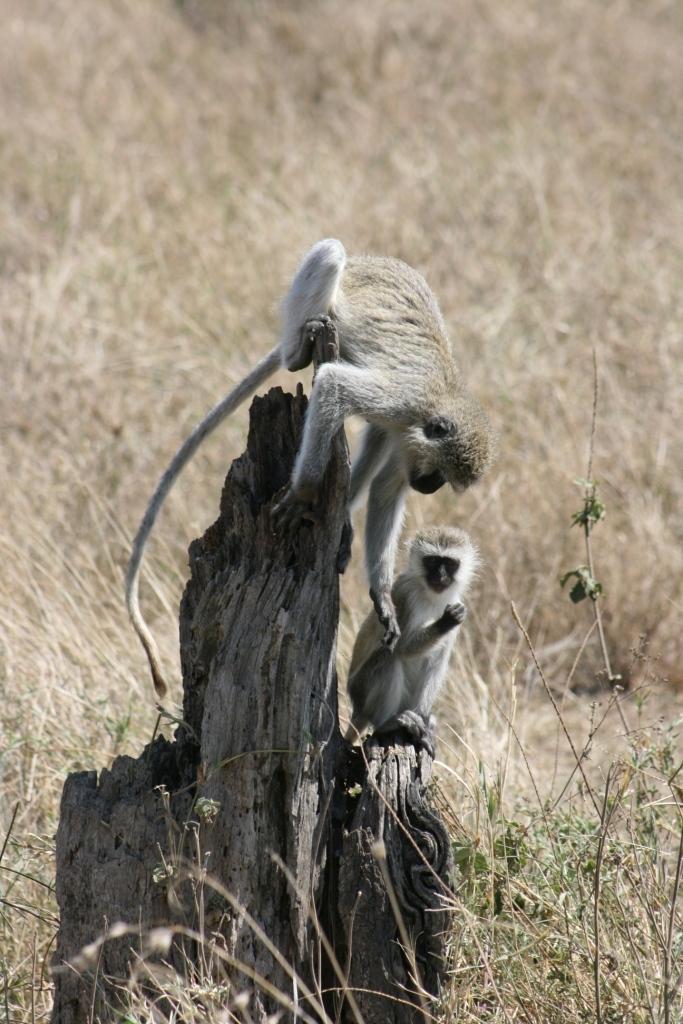In one or two sentences, can you explain what this image depicts? In this picture we can see grass at the bottom, there is some wood in the middle, we can see two monkeys in the front. 